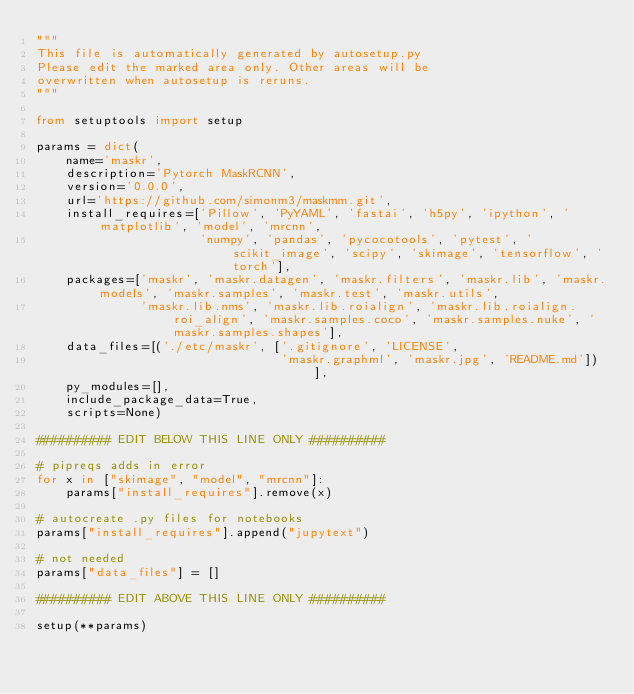Convert code to text. <code><loc_0><loc_0><loc_500><loc_500><_Python_>"""
This file is automatically generated by autosetup.py
Please edit the marked area only. Other areas will be
overwritten when autosetup is reruns.
"""

from setuptools import setup

params = dict(
    name='maskr',
    description='Pytorch MaskRCNN',
    version='0.0.0',
    url='https://github.com/simonm3/maskmm.git',
    install_requires=['Pillow', 'PyYAML', 'fastai', 'h5py', 'ipython', 'matplotlib', 'model', 'mrcnn',
                      'numpy', 'pandas', 'pycocotools', 'pytest', 'scikit_image', 'scipy', 'skimage', 'tensorflow', 'torch'],
    packages=['maskr', 'maskr.datagen', 'maskr.filters', 'maskr.lib', 'maskr.models', 'maskr.samples', 'maskr.test', 'maskr.utils',
              'maskr.lib.nms', 'maskr.lib.roialign', 'maskr.lib.roialign.roi_align', 'maskr.samples.coco', 'maskr.samples.nuke', 'maskr.samples.shapes'],
    data_files=[('./etc/maskr', ['.gitignore', 'LICENSE',
                                 'maskr.graphml', 'maskr.jpg', 'README.md'])],
    py_modules=[],
    include_package_data=True,
    scripts=None)

########## EDIT BELOW THIS LINE ONLY ##########

# pipreqs adds in error
for x in ["skimage", "model", "mrcnn"]:
    params["install_requires"].remove(x)

# autocreate .py files for notebooks
params["install_requires"].append("jupytext")

# not needed
params["data_files"] = []

########## EDIT ABOVE THIS LINE ONLY ##########

setup(**params)
</code> 